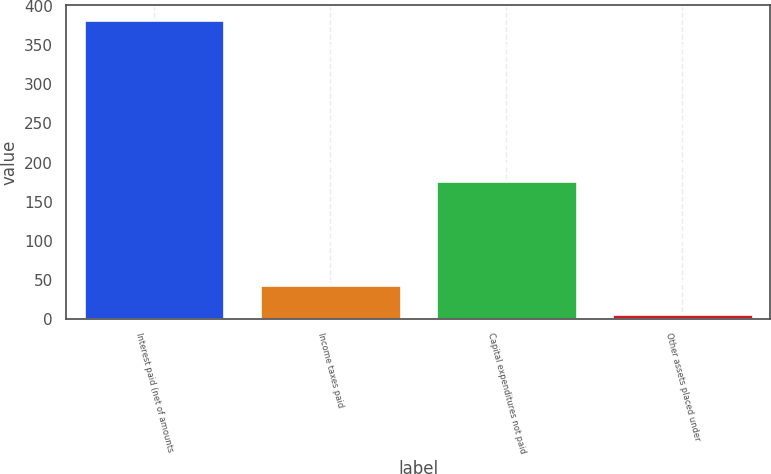Convert chart. <chart><loc_0><loc_0><loc_500><loc_500><bar_chart><fcel>Interest paid (net of amounts<fcel>Income taxes paid<fcel>Capital expenditures not paid<fcel>Other assets placed under<nl><fcel>382<fcel>43.6<fcel>176<fcel>6<nl></chart> 